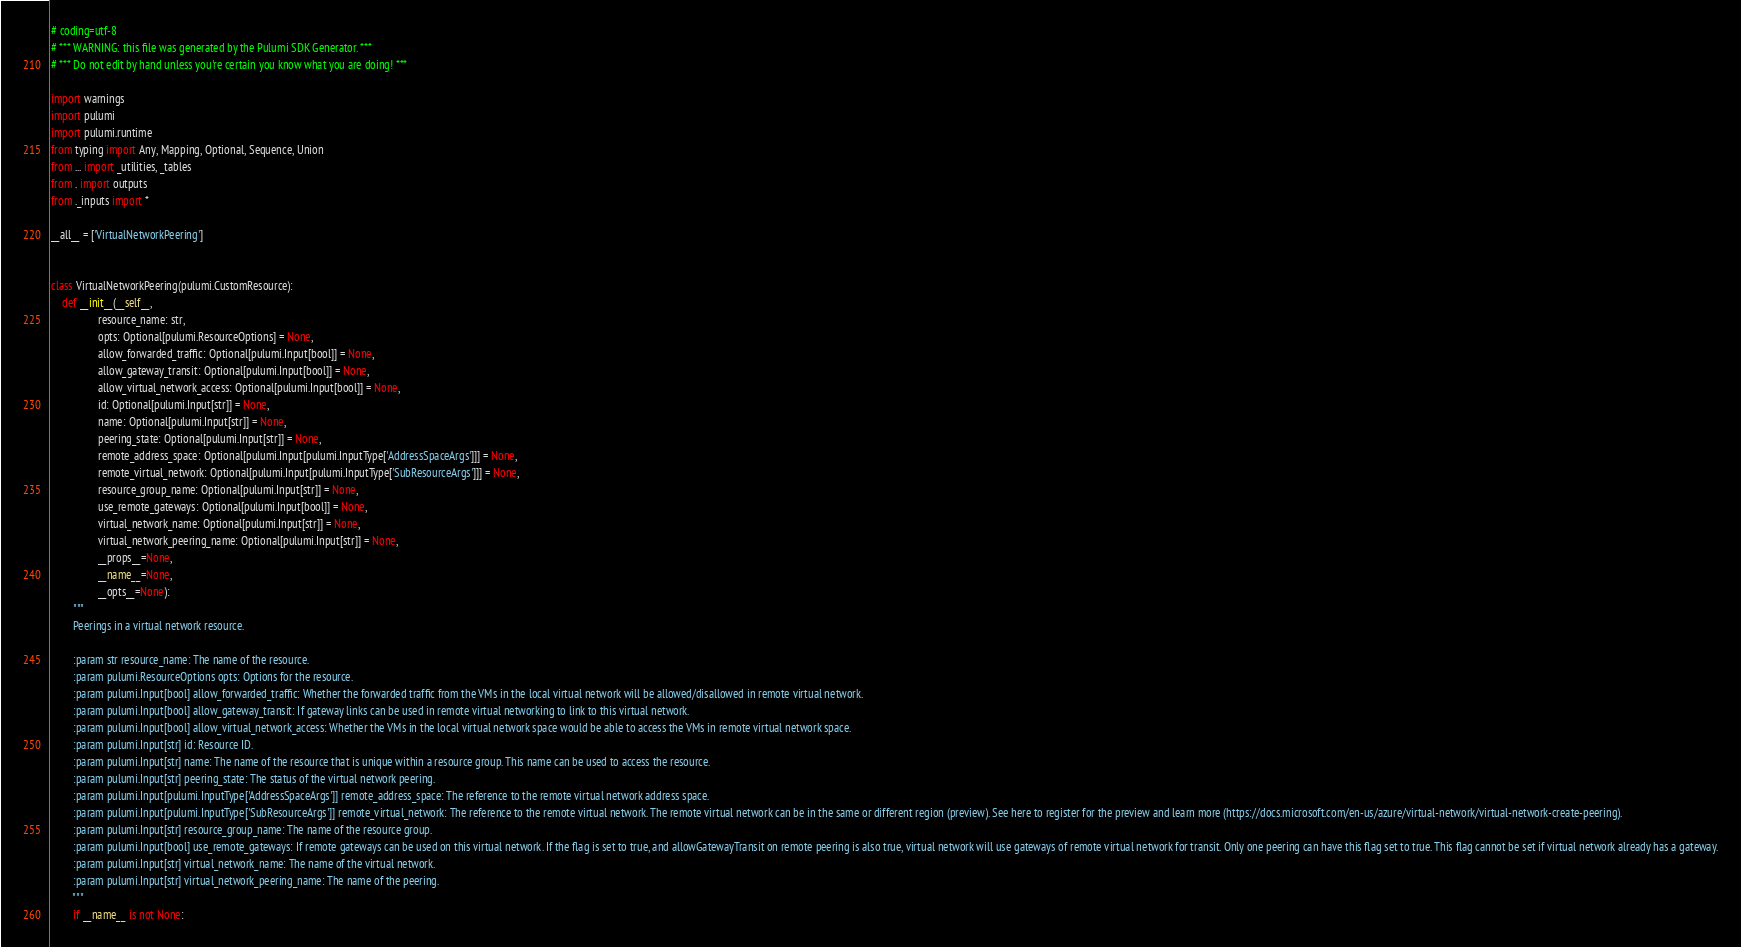Convert code to text. <code><loc_0><loc_0><loc_500><loc_500><_Python_># coding=utf-8
# *** WARNING: this file was generated by the Pulumi SDK Generator. ***
# *** Do not edit by hand unless you're certain you know what you are doing! ***

import warnings
import pulumi
import pulumi.runtime
from typing import Any, Mapping, Optional, Sequence, Union
from ... import _utilities, _tables
from . import outputs
from ._inputs import *

__all__ = ['VirtualNetworkPeering']


class VirtualNetworkPeering(pulumi.CustomResource):
    def __init__(__self__,
                 resource_name: str,
                 opts: Optional[pulumi.ResourceOptions] = None,
                 allow_forwarded_traffic: Optional[pulumi.Input[bool]] = None,
                 allow_gateway_transit: Optional[pulumi.Input[bool]] = None,
                 allow_virtual_network_access: Optional[pulumi.Input[bool]] = None,
                 id: Optional[pulumi.Input[str]] = None,
                 name: Optional[pulumi.Input[str]] = None,
                 peering_state: Optional[pulumi.Input[str]] = None,
                 remote_address_space: Optional[pulumi.Input[pulumi.InputType['AddressSpaceArgs']]] = None,
                 remote_virtual_network: Optional[pulumi.Input[pulumi.InputType['SubResourceArgs']]] = None,
                 resource_group_name: Optional[pulumi.Input[str]] = None,
                 use_remote_gateways: Optional[pulumi.Input[bool]] = None,
                 virtual_network_name: Optional[pulumi.Input[str]] = None,
                 virtual_network_peering_name: Optional[pulumi.Input[str]] = None,
                 __props__=None,
                 __name__=None,
                 __opts__=None):
        """
        Peerings in a virtual network resource.

        :param str resource_name: The name of the resource.
        :param pulumi.ResourceOptions opts: Options for the resource.
        :param pulumi.Input[bool] allow_forwarded_traffic: Whether the forwarded traffic from the VMs in the local virtual network will be allowed/disallowed in remote virtual network.
        :param pulumi.Input[bool] allow_gateway_transit: If gateway links can be used in remote virtual networking to link to this virtual network.
        :param pulumi.Input[bool] allow_virtual_network_access: Whether the VMs in the local virtual network space would be able to access the VMs in remote virtual network space.
        :param pulumi.Input[str] id: Resource ID.
        :param pulumi.Input[str] name: The name of the resource that is unique within a resource group. This name can be used to access the resource.
        :param pulumi.Input[str] peering_state: The status of the virtual network peering.
        :param pulumi.Input[pulumi.InputType['AddressSpaceArgs']] remote_address_space: The reference to the remote virtual network address space.
        :param pulumi.Input[pulumi.InputType['SubResourceArgs']] remote_virtual_network: The reference to the remote virtual network. The remote virtual network can be in the same or different region (preview). See here to register for the preview and learn more (https://docs.microsoft.com/en-us/azure/virtual-network/virtual-network-create-peering).
        :param pulumi.Input[str] resource_group_name: The name of the resource group.
        :param pulumi.Input[bool] use_remote_gateways: If remote gateways can be used on this virtual network. If the flag is set to true, and allowGatewayTransit on remote peering is also true, virtual network will use gateways of remote virtual network for transit. Only one peering can have this flag set to true. This flag cannot be set if virtual network already has a gateway.
        :param pulumi.Input[str] virtual_network_name: The name of the virtual network.
        :param pulumi.Input[str] virtual_network_peering_name: The name of the peering.
        """
        if __name__ is not None:</code> 